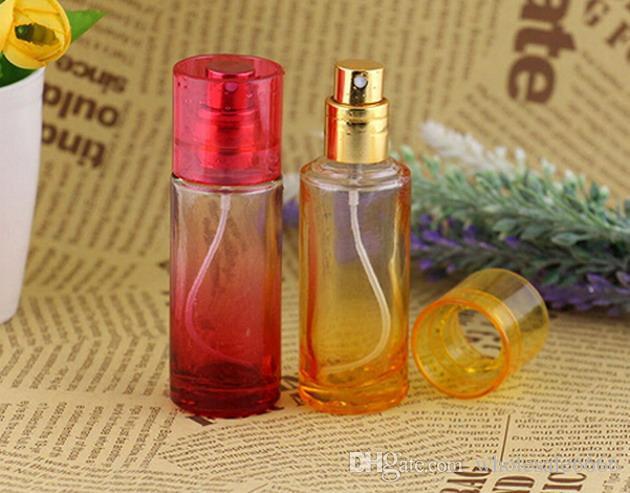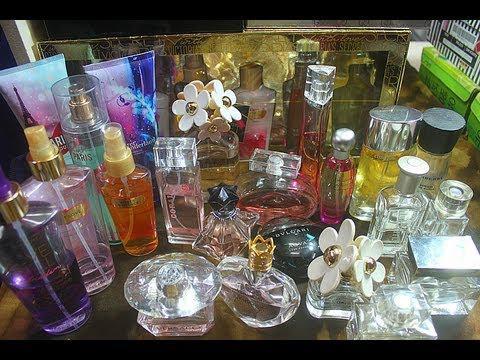The first image is the image on the left, the second image is the image on the right. Given the left and right images, does the statement "At least one image is less than four fragrances." hold true? Answer yes or no. Yes. The first image is the image on the left, the second image is the image on the right. For the images displayed, is the sentence "An image includes fragrance bottles sitting on a round mirrored tray with scalloped edges." factually correct? Answer yes or no. No. 